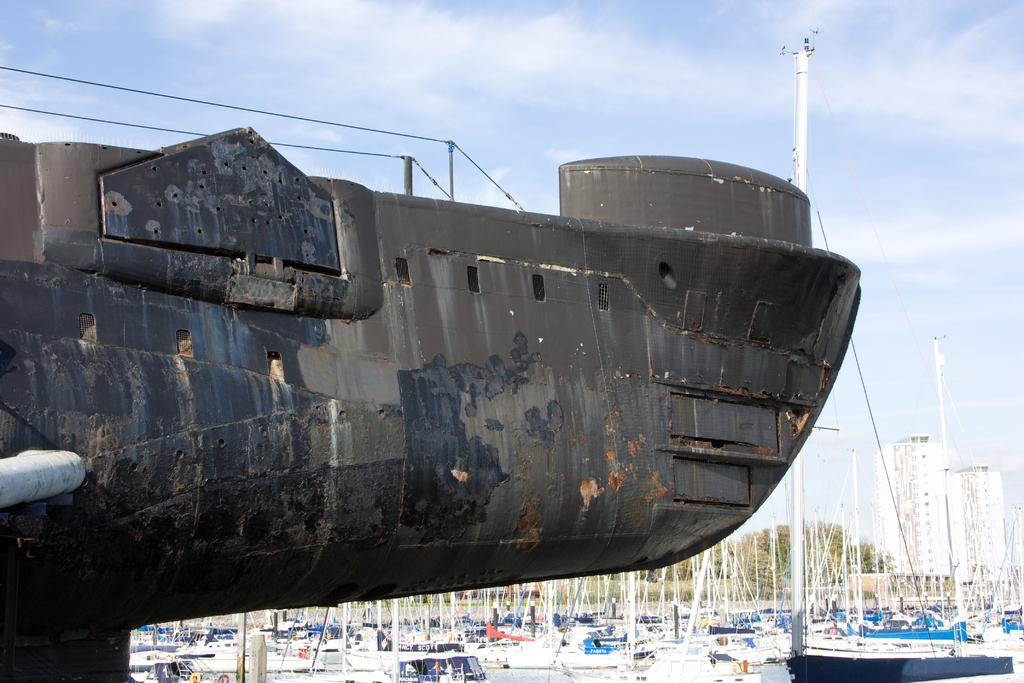What is located on the left side of the image? There is a submarine on the left side of the image. What can be seen in the background of the image? There are boats on the water, buildings, trees, and clouds in the background. Can you describe the sky in the image? The sky in the image has clouds. How many potatoes can be seen in the image? There are no potatoes present in the image. What is the duration of the minute shown in the image? There is no indication of time or duration in the image. 